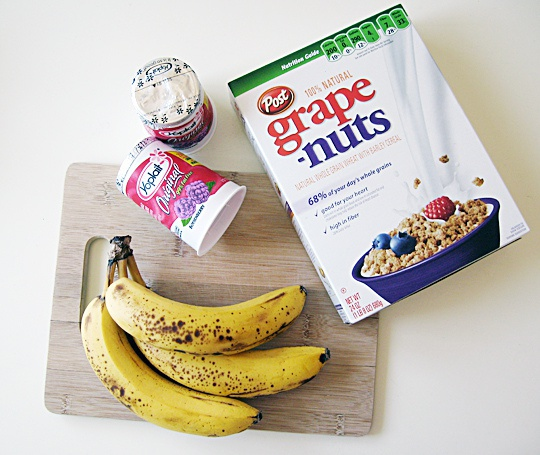Describe the objects in this image and their specific colors. I can see book in lightgray, navy, black, and darkgray tones, banana in lightgray, gold, khaki, and olive tones, cup in lightgray, white, darkgray, and violet tones, and cup in lightgray, darkgray, black, and maroon tones in this image. 